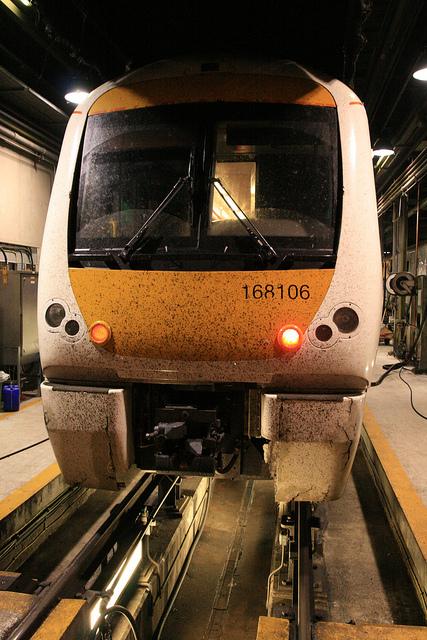Are the front lights of equal brightness?
Quick response, please. No. Is this train empty?
Write a very short answer. Yes. Is the train located outdoors?
Short answer required. No. 